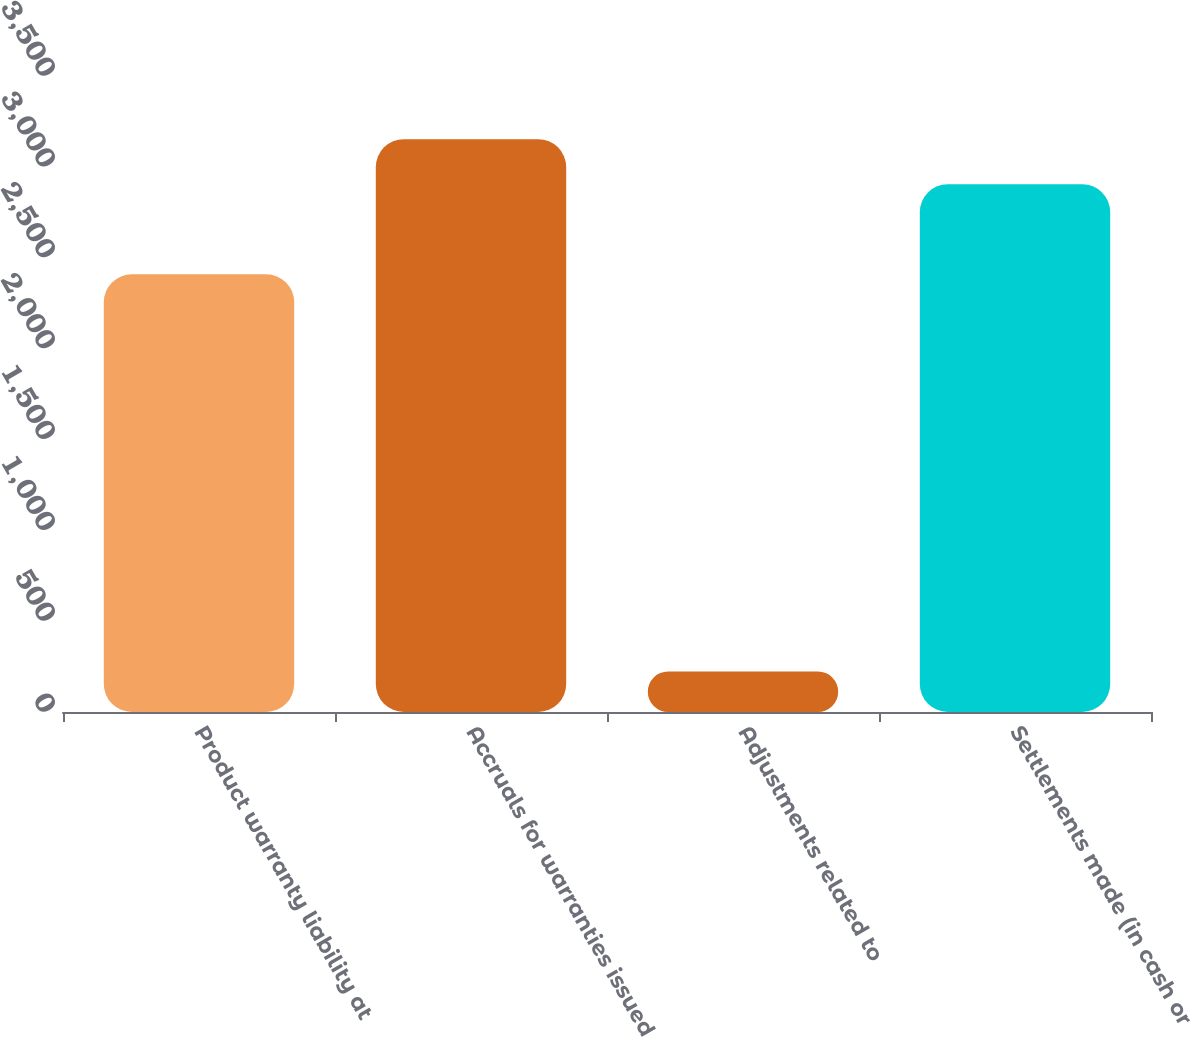Convert chart. <chart><loc_0><loc_0><loc_500><loc_500><bar_chart><fcel>Product warranty liability at<fcel>Accruals for warranties issued<fcel>Adjustments related to<fcel>Settlements made (in cash or<nl><fcel>2409<fcel>3152.4<fcel>223<fcel>2904.6<nl></chart> 